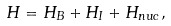Convert formula to latex. <formula><loc_0><loc_0><loc_500><loc_500>H = H _ { B } + H _ { I } + H _ { n u c } ,</formula> 